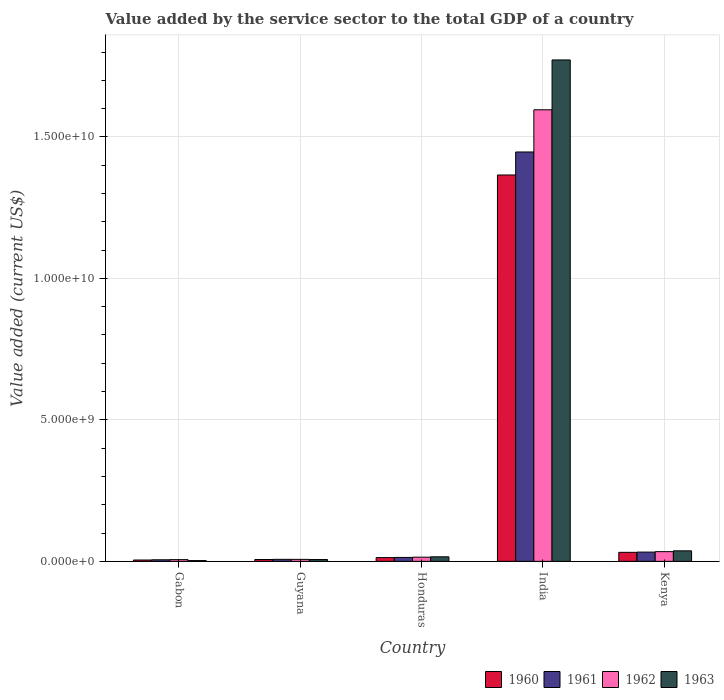How many groups of bars are there?
Your answer should be very brief. 5. Are the number of bars per tick equal to the number of legend labels?
Provide a short and direct response. Yes. How many bars are there on the 1st tick from the left?
Give a very brief answer. 4. How many bars are there on the 5th tick from the right?
Give a very brief answer. 4. What is the label of the 5th group of bars from the left?
Offer a very short reply. Kenya. What is the value added by the service sector to the total GDP in 1963 in Gabon?
Keep it short and to the point. 2.75e+07. Across all countries, what is the maximum value added by the service sector to the total GDP in 1963?
Offer a very short reply. 1.77e+1. Across all countries, what is the minimum value added by the service sector to the total GDP in 1962?
Keep it short and to the point. 6.13e+07. In which country was the value added by the service sector to the total GDP in 1962 minimum?
Your response must be concise. Gabon. What is the total value added by the service sector to the total GDP in 1961 in the graph?
Keep it short and to the point. 1.51e+1. What is the difference between the value added by the service sector to the total GDP in 1960 in Gabon and that in Guyana?
Your response must be concise. -1.76e+07. What is the difference between the value added by the service sector to the total GDP in 1960 in Gabon and the value added by the service sector to the total GDP in 1961 in Guyana?
Offer a very short reply. -2.34e+07. What is the average value added by the service sector to the total GDP in 1963 per country?
Ensure brevity in your answer.  3.67e+09. What is the difference between the value added by the service sector to the total GDP of/in 1963 and value added by the service sector to the total GDP of/in 1961 in India?
Offer a very short reply. 3.25e+09. In how many countries, is the value added by the service sector to the total GDP in 1961 greater than 3000000000 US$?
Your response must be concise. 1. What is the ratio of the value added by the service sector to the total GDP in 1961 in Gabon to that in Guyana?
Provide a succinct answer. 0.78. Is the value added by the service sector to the total GDP in 1960 in Guyana less than that in Honduras?
Provide a succinct answer. Yes. What is the difference between the highest and the second highest value added by the service sector to the total GDP in 1962?
Ensure brevity in your answer.  -1.58e+1. What is the difference between the highest and the lowest value added by the service sector to the total GDP in 1963?
Your answer should be very brief. 1.77e+1. Is the sum of the value added by the service sector to the total GDP in 1962 in Gabon and India greater than the maximum value added by the service sector to the total GDP in 1963 across all countries?
Your answer should be compact. No. What does the 3rd bar from the right in Gabon represents?
Provide a succinct answer. 1961. Is it the case that in every country, the sum of the value added by the service sector to the total GDP in 1961 and value added by the service sector to the total GDP in 1962 is greater than the value added by the service sector to the total GDP in 1960?
Your answer should be very brief. Yes. How many bars are there?
Provide a short and direct response. 20. Are all the bars in the graph horizontal?
Offer a very short reply. No. Are the values on the major ticks of Y-axis written in scientific E-notation?
Your response must be concise. Yes. How are the legend labels stacked?
Make the answer very short. Horizontal. What is the title of the graph?
Ensure brevity in your answer.  Value added by the service sector to the total GDP of a country. What is the label or title of the X-axis?
Keep it short and to the point. Country. What is the label or title of the Y-axis?
Your answer should be very brief. Value added (current US$). What is the Value added (current US$) in 1960 in Gabon?
Offer a very short reply. 4.80e+07. What is the Value added (current US$) of 1961 in Gabon?
Provide a short and direct response. 5.57e+07. What is the Value added (current US$) of 1962 in Gabon?
Offer a terse response. 6.13e+07. What is the Value added (current US$) in 1963 in Gabon?
Offer a very short reply. 2.75e+07. What is the Value added (current US$) of 1960 in Guyana?
Provide a succinct answer. 6.55e+07. What is the Value added (current US$) of 1961 in Guyana?
Provide a short and direct response. 7.13e+07. What is the Value added (current US$) in 1962 in Guyana?
Provide a succinct answer. 7.03e+07. What is the Value added (current US$) of 1963 in Guyana?
Give a very brief answer. 6.42e+07. What is the Value added (current US$) in 1960 in Honduras?
Offer a very short reply. 1.33e+08. What is the Value added (current US$) of 1961 in Honduras?
Offer a very short reply. 1.39e+08. What is the Value added (current US$) of 1962 in Honduras?
Provide a succinct answer. 1.48e+08. What is the Value added (current US$) in 1963 in Honduras?
Your answer should be very brief. 1.60e+08. What is the Value added (current US$) of 1960 in India?
Give a very brief answer. 1.37e+1. What is the Value added (current US$) in 1961 in India?
Your response must be concise. 1.45e+1. What is the Value added (current US$) of 1962 in India?
Offer a very short reply. 1.60e+1. What is the Value added (current US$) in 1963 in India?
Make the answer very short. 1.77e+1. What is the Value added (current US$) in 1960 in Kenya?
Provide a short and direct response. 3.19e+08. What is the Value added (current US$) of 1961 in Kenya?
Your answer should be compact. 3.28e+08. What is the Value added (current US$) in 1962 in Kenya?
Make the answer very short. 3.43e+08. What is the Value added (current US$) of 1963 in Kenya?
Provide a short and direct response. 3.72e+08. Across all countries, what is the maximum Value added (current US$) of 1960?
Ensure brevity in your answer.  1.37e+1. Across all countries, what is the maximum Value added (current US$) in 1961?
Your answer should be very brief. 1.45e+1. Across all countries, what is the maximum Value added (current US$) in 1962?
Your response must be concise. 1.60e+1. Across all countries, what is the maximum Value added (current US$) of 1963?
Your answer should be compact. 1.77e+1. Across all countries, what is the minimum Value added (current US$) of 1960?
Keep it short and to the point. 4.80e+07. Across all countries, what is the minimum Value added (current US$) in 1961?
Your answer should be compact. 5.57e+07. Across all countries, what is the minimum Value added (current US$) of 1962?
Give a very brief answer. 6.13e+07. Across all countries, what is the minimum Value added (current US$) of 1963?
Offer a very short reply. 2.75e+07. What is the total Value added (current US$) of 1960 in the graph?
Provide a succinct answer. 1.42e+1. What is the total Value added (current US$) in 1961 in the graph?
Provide a short and direct response. 1.51e+1. What is the total Value added (current US$) of 1962 in the graph?
Provide a short and direct response. 1.66e+1. What is the total Value added (current US$) of 1963 in the graph?
Make the answer very short. 1.83e+1. What is the difference between the Value added (current US$) in 1960 in Gabon and that in Guyana?
Keep it short and to the point. -1.76e+07. What is the difference between the Value added (current US$) in 1961 in Gabon and that in Guyana?
Keep it short and to the point. -1.56e+07. What is the difference between the Value added (current US$) of 1962 in Gabon and that in Guyana?
Offer a terse response. -9.03e+06. What is the difference between the Value added (current US$) of 1963 in Gabon and that in Guyana?
Your answer should be compact. -3.68e+07. What is the difference between the Value added (current US$) of 1960 in Gabon and that in Honduras?
Provide a succinct answer. -8.46e+07. What is the difference between the Value added (current US$) in 1961 in Gabon and that in Honduras?
Your answer should be very brief. -8.31e+07. What is the difference between the Value added (current US$) of 1962 in Gabon and that in Honduras?
Offer a terse response. -8.64e+07. What is the difference between the Value added (current US$) in 1963 in Gabon and that in Honduras?
Your answer should be compact. -1.33e+08. What is the difference between the Value added (current US$) of 1960 in Gabon and that in India?
Offer a very short reply. -1.36e+1. What is the difference between the Value added (current US$) in 1961 in Gabon and that in India?
Provide a succinct answer. -1.44e+1. What is the difference between the Value added (current US$) in 1962 in Gabon and that in India?
Offer a terse response. -1.59e+1. What is the difference between the Value added (current US$) of 1963 in Gabon and that in India?
Provide a short and direct response. -1.77e+1. What is the difference between the Value added (current US$) in 1960 in Gabon and that in Kenya?
Your response must be concise. -2.71e+08. What is the difference between the Value added (current US$) of 1961 in Gabon and that in Kenya?
Make the answer very short. -2.72e+08. What is the difference between the Value added (current US$) in 1962 in Gabon and that in Kenya?
Ensure brevity in your answer.  -2.82e+08. What is the difference between the Value added (current US$) in 1963 in Gabon and that in Kenya?
Provide a short and direct response. -3.44e+08. What is the difference between the Value added (current US$) of 1960 in Guyana and that in Honduras?
Ensure brevity in your answer.  -6.71e+07. What is the difference between the Value added (current US$) in 1961 in Guyana and that in Honduras?
Offer a terse response. -6.74e+07. What is the difference between the Value added (current US$) in 1962 in Guyana and that in Honduras?
Make the answer very short. -7.74e+07. What is the difference between the Value added (current US$) of 1963 in Guyana and that in Honduras?
Offer a terse response. -9.62e+07. What is the difference between the Value added (current US$) in 1960 in Guyana and that in India?
Offer a terse response. -1.36e+1. What is the difference between the Value added (current US$) of 1961 in Guyana and that in India?
Offer a terse response. -1.44e+1. What is the difference between the Value added (current US$) of 1962 in Guyana and that in India?
Your answer should be very brief. -1.59e+1. What is the difference between the Value added (current US$) of 1963 in Guyana and that in India?
Your answer should be very brief. -1.77e+1. What is the difference between the Value added (current US$) of 1960 in Guyana and that in Kenya?
Provide a succinct answer. -2.53e+08. What is the difference between the Value added (current US$) in 1961 in Guyana and that in Kenya?
Offer a very short reply. -2.56e+08. What is the difference between the Value added (current US$) of 1962 in Guyana and that in Kenya?
Your answer should be compact. -2.73e+08. What is the difference between the Value added (current US$) in 1963 in Guyana and that in Kenya?
Provide a short and direct response. -3.08e+08. What is the difference between the Value added (current US$) of 1960 in Honduras and that in India?
Your response must be concise. -1.35e+1. What is the difference between the Value added (current US$) in 1961 in Honduras and that in India?
Your response must be concise. -1.43e+1. What is the difference between the Value added (current US$) in 1962 in Honduras and that in India?
Keep it short and to the point. -1.58e+1. What is the difference between the Value added (current US$) in 1963 in Honduras and that in India?
Give a very brief answer. -1.76e+1. What is the difference between the Value added (current US$) in 1960 in Honduras and that in Kenya?
Make the answer very short. -1.86e+08. What is the difference between the Value added (current US$) in 1961 in Honduras and that in Kenya?
Your response must be concise. -1.89e+08. What is the difference between the Value added (current US$) in 1962 in Honduras and that in Kenya?
Your answer should be compact. -1.96e+08. What is the difference between the Value added (current US$) in 1963 in Honduras and that in Kenya?
Keep it short and to the point. -2.11e+08. What is the difference between the Value added (current US$) of 1960 in India and that in Kenya?
Your answer should be very brief. 1.33e+1. What is the difference between the Value added (current US$) in 1961 in India and that in Kenya?
Make the answer very short. 1.41e+1. What is the difference between the Value added (current US$) in 1962 in India and that in Kenya?
Provide a short and direct response. 1.56e+1. What is the difference between the Value added (current US$) in 1963 in India and that in Kenya?
Give a very brief answer. 1.73e+1. What is the difference between the Value added (current US$) of 1960 in Gabon and the Value added (current US$) of 1961 in Guyana?
Your response must be concise. -2.34e+07. What is the difference between the Value added (current US$) of 1960 in Gabon and the Value added (current US$) of 1962 in Guyana?
Your response must be concise. -2.23e+07. What is the difference between the Value added (current US$) in 1960 in Gabon and the Value added (current US$) in 1963 in Guyana?
Make the answer very short. -1.63e+07. What is the difference between the Value added (current US$) in 1961 in Gabon and the Value added (current US$) in 1962 in Guyana?
Give a very brief answer. -1.46e+07. What is the difference between the Value added (current US$) in 1961 in Gabon and the Value added (current US$) in 1963 in Guyana?
Provide a short and direct response. -8.53e+06. What is the difference between the Value added (current US$) in 1962 in Gabon and the Value added (current US$) in 1963 in Guyana?
Offer a very short reply. -2.96e+06. What is the difference between the Value added (current US$) in 1960 in Gabon and the Value added (current US$) in 1961 in Honduras?
Give a very brief answer. -9.08e+07. What is the difference between the Value added (current US$) of 1960 in Gabon and the Value added (current US$) of 1962 in Honduras?
Your response must be concise. -9.97e+07. What is the difference between the Value added (current US$) in 1960 in Gabon and the Value added (current US$) in 1963 in Honduras?
Ensure brevity in your answer.  -1.12e+08. What is the difference between the Value added (current US$) in 1961 in Gabon and the Value added (current US$) in 1962 in Honduras?
Provide a succinct answer. -9.20e+07. What is the difference between the Value added (current US$) in 1961 in Gabon and the Value added (current US$) in 1963 in Honduras?
Provide a succinct answer. -1.05e+08. What is the difference between the Value added (current US$) of 1962 in Gabon and the Value added (current US$) of 1963 in Honduras?
Provide a succinct answer. -9.92e+07. What is the difference between the Value added (current US$) in 1960 in Gabon and the Value added (current US$) in 1961 in India?
Make the answer very short. -1.44e+1. What is the difference between the Value added (current US$) in 1960 in Gabon and the Value added (current US$) in 1962 in India?
Your response must be concise. -1.59e+1. What is the difference between the Value added (current US$) in 1960 in Gabon and the Value added (current US$) in 1963 in India?
Ensure brevity in your answer.  -1.77e+1. What is the difference between the Value added (current US$) in 1961 in Gabon and the Value added (current US$) in 1962 in India?
Your answer should be very brief. -1.59e+1. What is the difference between the Value added (current US$) in 1961 in Gabon and the Value added (current US$) in 1963 in India?
Give a very brief answer. -1.77e+1. What is the difference between the Value added (current US$) of 1962 in Gabon and the Value added (current US$) of 1963 in India?
Your response must be concise. -1.77e+1. What is the difference between the Value added (current US$) in 1960 in Gabon and the Value added (current US$) in 1961 in Kenya?
Ensure brevity in your answer.  -2.80e+08. What is the difference between the Value added (current US$) of 1960 in Gabon and the Value added (current US$) of 1962 in Kenya?
Provide a succinct answer. -2.95e+08. What is the difference between the Value added (current US$) of 1960 in Gabon and the Value added (current US$) of 1963 in Kenya?
Your answer should be very brief. -3.24e+08. What is the difference between the Value added (current US$) in 1961 in Gabon and the Value added (current US$) in 1962 in Kenya?
Offer a terse response. -2.88e+08. What is the difference between the Value added (current US$) in 1961 in Gabon and the Value added (current US$) in 1963 in Kenya?
Ensure brevity in your answer.  -3.16e+08. What is the difference between the Value added (current US$) in 1962 in Gabon and the Value added (current US$) in 1963 in Kenya?
Keep it short and to the point. -3.11e+08. What is the difference between the Value added (current US$) in 1960 in Guyana and the Value added (current US$) in 1961 in Honduras?
Provide a short and direct response. -7.32e+07. What is the difference between the Value added (current US$) in 1960 in Guyana and the Value added (current US$) in 1962 in Honduras?
Provide a succinct answer. -8.21e+07. What is the difference between the Value added (current US$) of 1960 in Guyana and the Value added (current US$) of 1963 in Honduras?
Ensure brevity in your answer.  -9.49e+07. What is the difference between the Value added (current US$) of 1961 in Guyana and the Value added (current US$) of 1962 in Honduras?
Offer a terse response. -7.63e+07. What is the difference between the Value added (current US$) in 1961 in Guyana and the Value added (current US$) in 1963 in Honduras?
Your response must be concise. -8.91e+07. What is the difference between the Value added (current US$) of 1962 in Guyana and the Value added (current US$) of 1963 in Honduras?
Offer a terse response. -9.02e+07. What is the difference between the Value added (current US$) in 1960 in Guyana and the Value added (current US$) in 1961 in India?
Give a very brief answer. -1.44e+1. What is the difference between the Value added (current US$) in 1960 in Guyana and the Value added (current US$) in 1962 in India?
Provide a short and direct response. -1.59e+1. What is the difference between the Value added (current US$) in 1960 in Guyana and the Value added (current US$) in 1963 in India?
Your answer should be compact. -1.77e+1. What is the difference between the Value added (current US$) of 1961 in Guyana and the Value added (current US$) of 1962 in India?
Offer a terse response. -1.59e+1. What is the difference between the Value added (current US$) of 1961 in Guyana and the Value added (current US$) of 1963 in India?
Give a very brief answer. -1.76e+1. What is the difference between the Value added (current US$) in 1962 in Guyana and the Value added (current US$) in 1963 in India?
Keep it short and to the point. -1.77e+1. What is the difference between the Value added (current US$) in 1960 in Guyana and the Value added (current US$) in 1961 in Kenya?
Your answer should be very brief. -2.62e+08. What is the difference between the Value added (current US$) in 1960 in Guyana and the Value added (current US$) in 1962 in Kenya?
Offer a terse response. -2.78e+08. What is the difference between the Value added (current US$) in 1960 in Guyana and the Value added (current US$) in 1963 in Kenya?
Your answer should be compact. -3.06e+08. What is the difference between the Value added (current US$) of 1961 in Guyana and the Value added (current US$) of 1962 in Kenya?
Provide a succinct answer. -2.72e+08. What is the difference between the Value added (current US$) of 1961 in Guyana and the Value added (current US$) of 1963 in Kenya?
Make the answer very short. -3.00e+08. What is the difference between the Value added (current US$) of 1962 in Guyana and the Value added (current US$) of 1963 in Kenya?
Provide a succinct answer. -3.01e+08. What is the difference between the Value added (current US$) of 1960 in Honduras and the Value added (current US$) of 1961 in India?
Your answer should be compact. -1.43e+1. What is the difference between the Value added (current US$) of 1960 in Honduras and the Value added (current US$) of 1962 in India?
Ensure brevity in your answer.  -1.58e+1. What is the difference between the Value added (current US$) of 1960 in Honduras and the Value added (current US$) of 1963 in India?
Offer a very short reply. -1.76e+1. What is the difference between the Value added (current US$) of 1961 in Honduras and the Value added (current US$) of 1962 in India?
Keep it short and to the point. -1.58e+1. What is the difference between the Value added (current US$) in 1961 in Honduras and the Value added (current US$) in 1963 in India?
Give a very brief answer. -1.76e+1. What is the difference between the Value added (current US$) of 1962 in Honduras and the Value added (current US$) of 1963 in India?
Offer a very short reply. -1.76e+1. What is the difference between the Value added (current US$) in 1960 in Honduras and the Value added (current US$) in 1961 in Kenya?
Keep it short and to the point. -1.95e+08. What is the difference between the Value added (current US$) of 1960 in Honduras and the Value added (current US$) of 1962 in Kenya?
Your answer should be compact. -2.11e+08. What is the difference between the Value added (current US$) of 1960 in Honduras and the Value added (current US$) of 1963 in Kenya?
Your answer should be very brief. -2.39e+08. What is the difference between the Value added (current US$) of 1961 in Honduras and the Value added (current US$) of 1962 in Kenya?
Offer a terse response. -2.05e+08. What is the difference between the Value added (current US$) of 1961 in Honduras and the Value added (current US$) of 1963 in Kenya?
Make the answer very short. -2.33e+08. What is the difference between the Value added (current US$) in 1962 in Honduras and the Value added (current US$) in 1963 in Kenya?
Your answer should be very brief. -2.24e+08. What is the difference between the Value added (current US$) in 1960 in India and the Value added (current US$) in 1961 in Kenya?
Give a very brief answer. 1.33e+1. What is the difference between the Value added (current US$) of 1960 in India and the Value added (current US$) of 1962 in Kenya?
Make the answer very short. 1.33e+1. What is the difference between the Value added (current US$) of 1960 in India and the Value added (current US$) of 1963 in Kenya?
Offer a very short reply. 1.33e+1. What is the difference between the Value added (current US$) in 1961 in India and the Value added (current US$) in 1962 in Kenya?
Your answer should be compact. 1.41e+1. What is the difference between the Value added (current US$) in 1961 in India and the Value added (current US$) in 1963 in Kenya?
Keep it short and to the point. 1.41e+1. What is the difference between the Value added (current US$) of 1962 in India and the Value added (current US$) of 1963 in Kenya?
Your answer should be very brief. 1.56e+1. What is the average Value added (current US$) in 1960 per country?
Offer a very short reply. 2.84e+09. What is the average Value added (current US$) of 1961 per country?
Offer a very short reply. 3.01e+09. What is the average Value added (current US$) of 1962 per country?
Offer a terse response. 3.32e+09. What is the average Value added (current US$) in 1963 per country?
Offer a terse response. 3.67e+09. What is the difference between the Value added (current US$) of 1960 and Value added (current US$) of 1961 in Gabon?
Provide a succinct answer. -7.74e+06. What is the difference between the Value added (current US$) of 1960 and Value added (current US$) of 1962 in Gabon?
Make the answer very short. -1.33e+07. What is the difference between the Value added (current US$) in 1960 and Value added (current US$) in 1963 in Gabon?
Ensure brevity in your answer.  2.05e+07. What is the difference between the Value added (current US$) in 1961 and Value added (current US$) in 1962 in Gabon?
Your answer should be compact. -5.57e+06. What is the difference between the Value added (current US$) in 1961 and Value added (current US$) in 1963 in Gabon?
Your response must be concise. 2.82e+07. What is the difference between the Value added (current US$) of 1962 and Value added (current US$) of 1963 in Gabon?
Your answer should be very brief. 3.38e+07. What is the difference between the Value added (current US$) of 1960 and Value added (current US$) of 1961 in Guyana?
Offer a terse response. -5.83e+06. What is the difference between the Value added (current US$) of 1960 and Value added (current US$) of 1962 in Guyana?
Give a very brief answer. -4.78e+06. What is the difference between the Value added (current US$) in 1960 and Value added (current US$) in 1963 in Guyana?
Your response must be concise. 1.28e+06. What is the difference between the Value added (current US$) in 1961 and Value added (current US$) in 1962 in Guyana?
Give a very brief answer. 1.05e+06. What is the difference between the Value added (current US$) in 1961 and Value added (current US$) in 1963 in Guyana?
Keep it short and to the point. 7.12e+06. What is the difference between the Value added (current US$) in 1962 and Value added (current US$) in 1963 in Guyana?
Offer a very short reply. 6.07e+06. What is the difference between the Value added (current US$) of 1960 and Value added (current US$) of 1961 in Honduras?
Offer a terse response. -6.15e+06. What is the difference between the Value added (current US$) of 1960 and Value added (current US$) of 1962 in Honduras?
Offer a terse response. -1.50e+07. What is the difference between the Value added (current US$) of 1960 and Value added (current US$) of 1963 in Honduras?
Your answer should be compact. -2.78e+07. What is the difference between the Value added (current US$) in 1961 and Value added (current US$) in 1962 in Honduras?
Ensure brevity in your answer.  -8.90e+06. What is the difference between the Value added (current US$) of 1961 and Value added (current US$) of 1963 in Honduras?
Give a very brief answer. -2.17e+07. What is the difference between the Value added (current US$) of 1962 and Value added (current US$) of 1963 in Honduras?
Make the answer very short. -1.28e+07. What is the difference between the Value added (current US$) of 1960 and Value added (current US$) of 1961 in India?
Give a very brief answer. -8.13e+08. What is the difference between the Value added (current US$) in 1960 and Value added (current US$) in 1962 in India?
Make the answer very short. -2.30e+09. What is the difference between the Value added (current US$) in 1960 and Value added (current US$) in 1963 in India?
Make the answer very short. -4.07e+09. What is the difference between the Value added (current US$) in 1961 and Value added (current US$) in 1962 in India?
Your response must be concise. -1.49e+09. What is the difference between the Value added (current US$) in 1961 and Value added (current US$) in 1963 in India?
Your response must be concise. -3.25e+09. What is the difference between the Value added (current US$) in 1962 and Value added (current US$) in 1963 in India?
Offer a terse response. -1.76e+09. What is the difference between the Value added (current US$) in 1960 and Value added (current US$) in 1961 in Kenya?
Your answer should be compact. -8.81e+06. What is the difference between the Value added (current US$) of 1960 and Value added (current US$) of 1962 in Kenya?
Offer a very short reply. -2.43e+07. What is the difference between the Value added (current US$) of 1960 and Value added (current US$) of 1963 in Kenya?
Make the answer very short. -5.28e+07. What is the difference between the Value added (current US$) in 1961 and Value added (current US$) in 1962 in Kenya?
Provide a short and direct response. -1.55e+07. What is the difference between the Value added (current US$) of 1961 and Value added (current US$) of 1963 in Kenya?
Your answer should be compact. -4.40e+07. What is the difference between the Value added (current US$) in 1962 and Value added (current US$) in 1963 in Kenya?
Offer a very short reply. -2.84e+07. What is the ratio of the Value added (current US$) in 1960 in Gabon to that in Guyana?
Give a very brief answer. 0.73. What is the ratio of the Value added (current US$) of 1961 in Gabon to that in Guyana?
Make the answer very short. 0.78. What is the ratio of the Value added (current US$) of 1962 in Gabon to that in Guyana?
Provide a short and direct response. 0.87. What is the ratio of the Value added (current US$) of 1963 in Gabon to that in Guyana?
Provide a succinct answer. 0.43. What is the ratio of the Value added (current US$) of 1960 in Gabon to that in Honduras?
Make the answer very short. 0.36. What is the ratio of the Value added (current US$) of 1961 in Gabon to that in Honduras?
Your answer should be very brief. 0.4. What is the ratio of the Value added (current US$) in 1962 in Gabon to that in Honduras?
Offer a very short reply. 0.41. What is the ratio of the Value added (current US$) of 1963 in Gabon to that in Honduras?
Keep it short and to the point. 0.17. What is the ratio of the Value added (current US$) in 1960 in Gabon to that in India?
Offer a terse response. 0. What is the ratio of the Value added (current US$) in 1961 in Gabon to that in India?
Make the answer very short. 0. What is the ratio of the Value added (current US$) of 1962 in Gabon to that in India?
Your answer should be compact. 0. What is the ratio of the Value added (current US$) of 1963 in Gabon to that in India?
Ensure brevity in your answer.  0. What is the ratio of the Value added (current US$) of 1960 in Gabon to that in Kenya?
Give a very brief answer. 0.15. What is the ratio of the Value added (current US$) of 1961 in Gabon to that in Kenya?
Provide a succinct answer. 0.17. What is the ratio of the Value added (current US$) of 1962 in Gabon to that in Kenya?
Keep it short and to the point. 0.18. What is the ratio of the Value added (current US$) of 1963 in Gabon to that in Kenya?
Your response must be concise. 0.07. What is the ratio of the Value added (current US$) of 1960 in Guyana to that in Honduras?
Provide a short and direct response. 0.49. What is the ratio of the Value added (current US$) in 1961 in Guyana to that in Honduras?
Your answer should be very brief. 0.51. What is the ratio of the Value added (current US$) in 1962 in Guyana to that in Honduras?
Keep it short and to the point. 0.48. What is the ratio of the Value added (current US$) in 1963 in Guyana to that in Honduras?
Ensure brevity in your answer.  0.4. What is the ratio of the Value added (current US$) in 1960 in Guyana to that in India?
Your answer should be compact. 0. What is the ratio of the Value added (current US$) in 1961 in Guyana to that in India?
Your answer should be very brief. 0. What is the ratio of the Value added (current US$) in 1962 in Guyana to that in India?
Offer a very short reply. 0. What is the ratio of the Value added (current US$) of 1963 in Guyana to that in India?
Offer a terse response. 0. What is the ratio of the Value added (current US$) of 1960 in Guyana to that in Kenya?
Your answer should be compact. 0.21. What is the ratio of the Value added (current US$) of 1961 in Guyana to that in Kenya?
Make the answer very short. 0.22. What is the ratio of the Value added (current US$) of 1962 in Guyana to that in Kenya?
Offer a very short reply. 0.2. What is the ratio of the Value added (current US$) of 1963 in Guyana to that in Kenya?
Keep it short and to the point. 0.17. What is the ratio of the Value added (current US$) of 1960 in Honduras to that in India?
Give a very brief answer. 0.01. What is the ratio of the Value added (current US$) of 1961 in Honduras to that in India?
Provide a short and direct response. 0.01. What is the ratio of the Value added (current US$) in 1962 in Honduras to that in India?
Ensure brevity in your answer.  0.01. What is the ratio of the Value added (current US$) in 1963 in Honduras to that in India?
Offer a very short reply. 0.01. What is the ratio of the Value added (current US$) in 1960 in Honduras to that in Kenya?
Give a very brief answer. 0.42. What is the ratio of the Value added (current US$) in 1961 in Honduras to that in Kenya?
Your answer should be compact. 0.42. What is the ratio of the Value added (current US$) of 1962 in Honduras to that in Kenya?
Provide a succinct answer. 0.43. What is the ratio of the Value added (current US$) in 1963 in Honduras to that in Kenya?
Your answer should be very brief. 0.43. What is the ratio of the Value added (current US$) of 1960 in India to that in Kenya?
Provide a succinct answer. 42.81. What is the ratio of the Value added (current US$) in 1961 in India to that in Kenya?
Ensure brevity in your answer.  44.14. What is the ratio of the Value added (current US$) of 1962 in India to that in Kenya?
Provide a succinct answer. 46.48. What is the ratio of the Value added (current US$) in 1963 in India to that in Kenya?
Offer a very short reply. 47.67. What is the difference between the highest and the second highest Value added (current US$) of 1960?
Provide a short and direct response. 1.33e+1. What is the difference between the highest and the second highest Value added (current US$) of 1961?
Offer a terse response. 1.41e+1. What is the difference between the highest and the second highest Value added (current US$) in 1962?
Offer a very short reply. 1.56e+1. What is the difference between the highest and the second highest Value added (current US$) in 1963?
Your answer should be very brief. 1.73e+1. What is the difference between the highest and the lowest Value added (current US$) of 1960?
Ensure brevity in your answer.  1.36e+1. What is the difference between the highest and the lowest Value added (current US$) of 1961?
Ensure brevity in your answer.  1.44e+1. What is the difference between the highest and the lowest Value added (current US$) of 1962?
Your answer should be compact. 1.59e+1. What is the difference between the highest and the lowest Value added (current US$) of 1963?
Your answer should be very brief. 1.77e+1. 